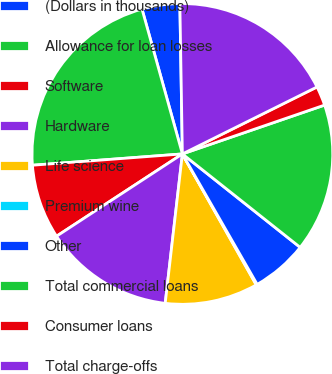Convert chart. <chart><loc_0><loc_0><loc_500><loc_500><pie_chart><fcel>(Dollars in thousands)<fcel>Allowance for loan losses<fcel>Software<fcel>Hardware<fcel>Life science<fcel>Premium wine<fcel>Other<fcel>Total commercial loans<fcel>Consumer loans<fcel>Total charge-offs<nl><fcel>4.06%<fcel>21.87%<fcel>8.02%<fcel>13.96%<fcel>10.0%<fcel>0.11%<fcel>6.04%<fcel>15.94%<fcel>2.08%<fcel>17.92%<nl></chart> 